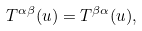<formula> <loc_0><loc_0><loc_500><loc_500>T ^ { \alpha \beta } ( u ) = T ^ { \beta \alpha } ( u ) ,</formula> 